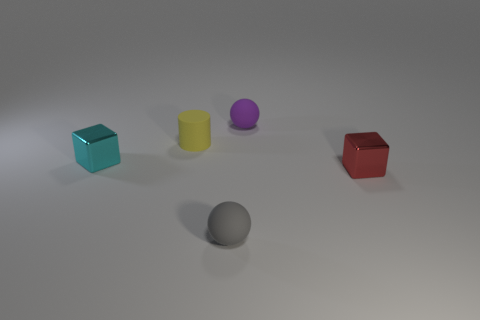Is the small cyan block made of the same material as the small cube to the right of the cyan metal block?
Your answer should be very brief. Yes. What is the color of the rubber ball that is behind the red cube?
Your response must be concise. Purple. There is a shiny thing on the right side of the tiny yellow matte cylinder; are there any gray rubber objects that are right of it?
Your response must be concise. No. There is a rubber sphere that is left of the tiny purple object; does it have the same color as the ball right of the tiny gray matte ball?
Make the answer very short. No. What number of purple objects are on the left side of the tiny red object?
Give a very brief answer. 1. How many other small rubber cylinders are the same color as the small rubber cylinder?
Offer a very short reply. 0. Does the cube right of the tiny gray ball have the same material as the tiny gray sphere?
Ensure brevity in your answer.  No. How many yellow objects have the same material as the purple thing?
Provide a short and direct response. 1. Is the number of tiny yellow matte objects that are on the right side of the red shiny object greater than the number of tiny cyan cubes?
Provide a succinct answer. No. Is there a red thing that has the same shape as the small gray matte object?
Give a very brief answer. No. 